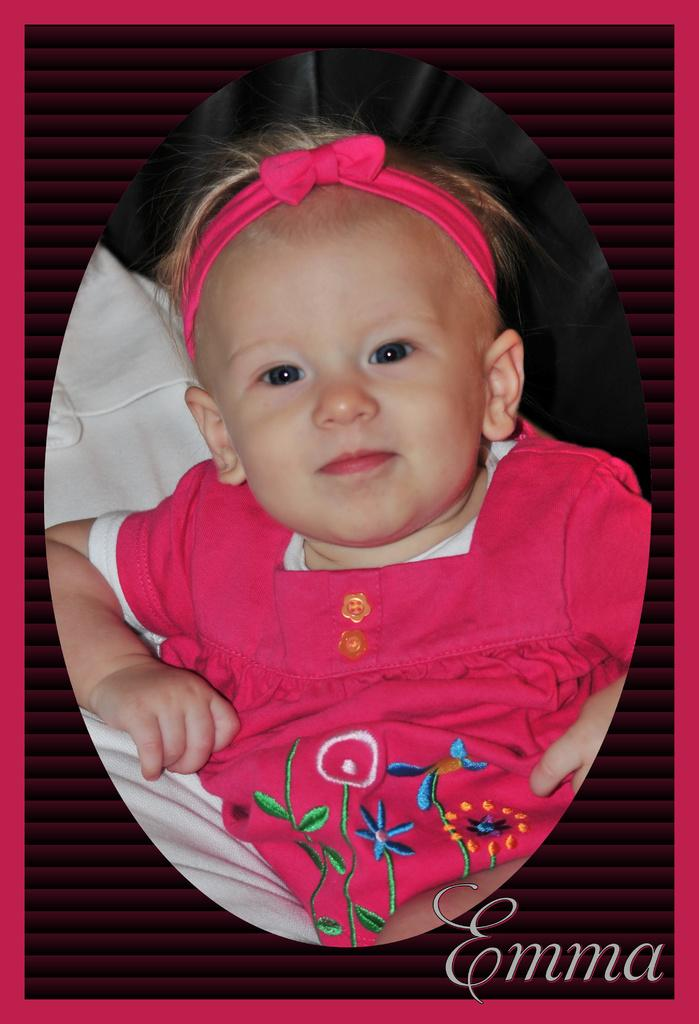What type of visual might this image be? The image might be a poster. Who is the main subject in the image? There is a girl in the center of the image. What is the girl wearing on her head? The girl is wearing a headband. What can be seen in the background of the image? There is a blanket in the background of the image. What is present at the bottom of the image? There is text at the bottom of the image. What type of needle is the girl holding in the image? There is no needle present in the image; the girl is not holding anything. What type of cup is on the table in the image? There is no table or cup present in the image. 